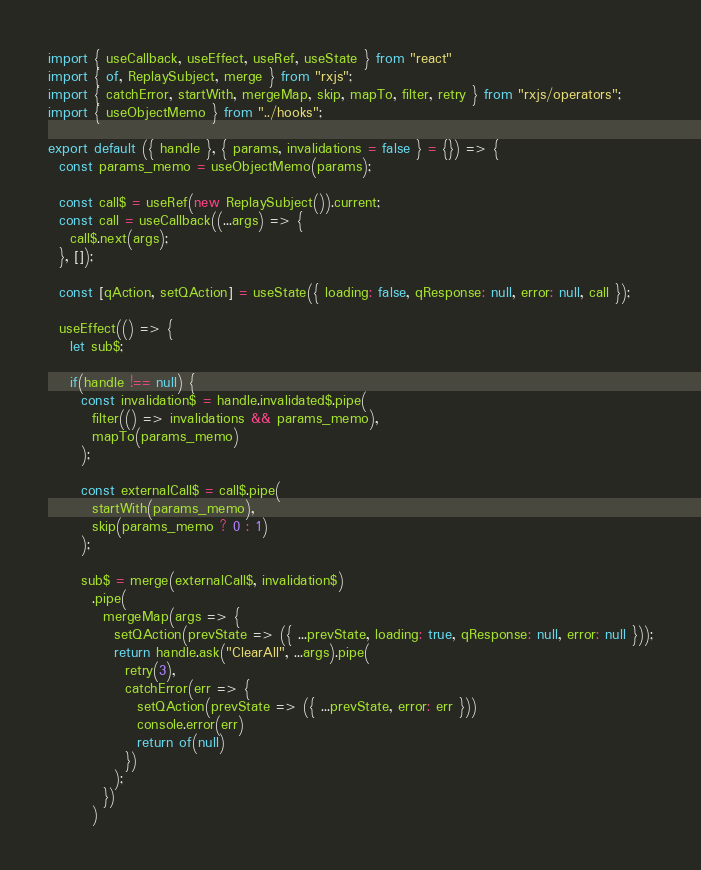<code> <loc_0><loc_0><loc_500><loc_500><_JavaScript_>import { useCallback, useEffect, useRef, useState } from "react"
import { of, ReplaySubject, merge } from "rxjs";
import { catchError, startWith, mergeMap, skip, mapTo, filter, retry } from "rxjs/operators";
import { useObjectMemo } from "../hooks";

export default ({ handle }, { params, invalidations = false } = {}) => {
  const params_memo = useObjectMemo(params);

  const call$ = useRef(new ReplaySubject()).current;
  const call = useCallback((...args) => {
    call$.next(args);
  }, []);

  const [qAction, setQAction] = useState({ loading: false, qResponse: null, error: null, call });

  useEffect(() => {
    let sub$;

    if(handle !== null) {
      const invalidation$ = handle.invalidated$.pipe(
        filter(() => invalidations && params_memo),
        mapTo(params_memo)
      );

      const externalCall$ = call$.pipe(
        startWith(params_memo),
        skip(params_memo ? 0 : 1)
      );

      sub$ = merge(externalCall$, invalidation$)
        .pipe(
          mergeMap(args => {
            setQAction(prevState => ({ ...prevState, loading: true, qResponse: null, error: null }));
            return handle.ask("ClearAll", ...args).pipe(
              retry(3),
              catchError(err => {
                setQAction(prevState => ({ ...prevState, error: err }))
                console.error(err)
                return of(null)
              })
            );
          })
        )</code> 